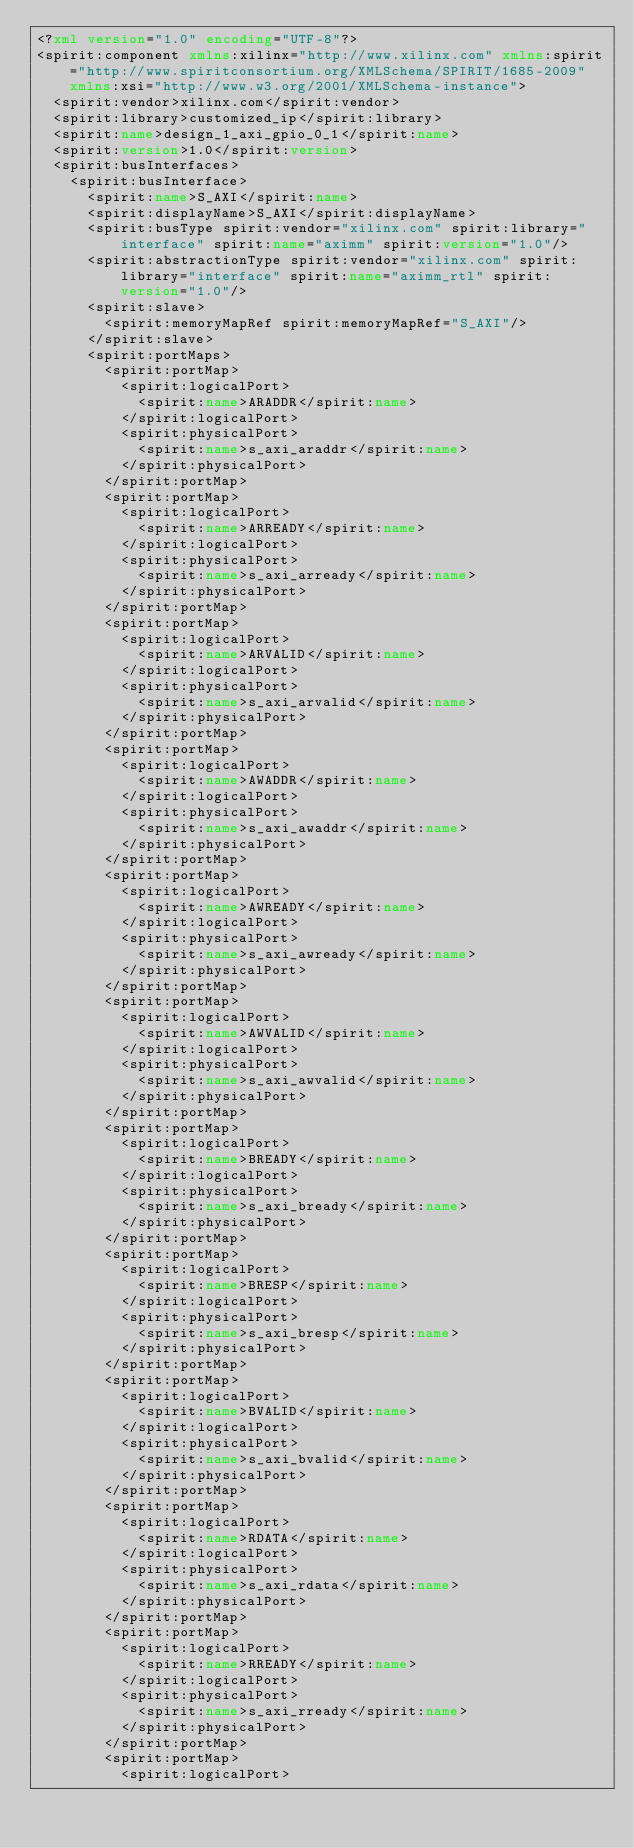<code> <loc_0><loc_0><loc_500><loc_500><_XML_><?xml version="1.0" encoding="UTF-8"?>
<spirit:component xmlns:xilinx="http://www.xilinx.com" xmlns:spirit="http://www.spiritconsortium.org/XMLSchema/SPIRIT/1685-2009" xmlns:xsi="http://www.w3.org/2001/XMLSchema-instance">
  <spirit:vendor>xilinx.com</spirit:vendor>
  <spirit:library>customized_ip</spirit:library>
  <spirit:name>design_1_axi_gpio_0_1</spirit:name>
  <spirit:version>1.0</spirit:version>
  <spirit:busInterfaces>
    <spirit:busInterface>
      <spirit:name>S_AXI</spirit:name>
      <spirit:displayName>S_AXI</spirit:displayName>
      <spirit:busType spirit:vendor="xilinx.com" spirit:library="interface" spirit:name="aximm" spirit:version="1.0"/>
      <spirit:abstractionType spirit:vendor="xilinx.com" spirit:library="interface" spirit:name="aximm_rtl" spirit:version="1.0"/>
      <spirit:slave>
        <spirit:memoryMapRef spirit:memoryMapRef="S_AXI"/>
      </spirit:slave>
      <spirit:portMaps>
        <spirit:portMap>
          <spirit:logicalPort>
            <spirit:name>ARADDR</spirit:name>
          </spirit:logicalPort>
          <spirit:physicalPort>
            <spirit:name>s_axi_araddr</spirit:name>
          </spirit:physicalPort>
        </spirit:portMap>
        <spirit:portMap>
          <spirit:logicalPort>
            <spirit:name>ARREADY</spirit:name>
          </spirit:logicalPort>
          <spirit:physicalPort>
            <spirit:name>s_axi_arready</spirit:name>
          </spirit:physicalPort>
        </spirit:portMap>
        <spirit:portMap>
          <spirit:logicalPort>
            <spirit:name>ARVALID</spirit:name>
          </spirit:logicalPort>
          <spirit:physicalPort>
            <spirit:name>s_axi_arvalid</spirit:name>
          </spirit:physicalPort>
        </spirit:portMap>
        <spirit:portMap>
          <spirit:logicalPort>
            <spirit:name>AWADDR</spirit:name>
          </spirit:logicalPort>
          <spirit:physicalPort>
            <spirit:name>s_axi_awaddr</spirit:name>
          </spirit:physicalPort>
        </spirit:portMap>
        <spirit:portMap>
          <spirit:logicalPort>
            <spirit:name>AWREADY</spirit:name>
          </spirit:logicalPort>
          <spirit:physicalPort>
            <spirit:name>s_axi_awready</spirit:name>
          </spirit:physicalPort>
        </spirit:portMap>
        <spirit:portMap>
          <spirit:logicalPort>
            <spirit:name>AWVALID</spirit:name>
          </spirit:logicalPort>
          <spirit:physicalPort>
            <spirit:name>s_axi_awvalid</spirit:name>
          </spirit:physicalPort>
        </spirit:portMap>
        <spirit:portMap>
          <spirit:logicalPort>
            <spirit:name>BREADY</spirit:name>
          </spirit:logicalPort>
          <spirit:physicalPort>
            <spirit:name>s_axi_bready</spirit:name>
          </spirit:physicalPort>
        </spirit:portMap>
        <spirit:portMap>
          <spirit:logicalPort>
            <spirit:name>BRESP</spirit:name>
          </spirit:logicalPort>
          <spirit:physicalPort>
            <spirit:name>s_axi_bresp</spirit:name>
          </spirit:physicalPort>
        </spirit:portMap>
        <spirit:portMap>
          <spirit:logicalPort>
            <spirit:name>BVALID</spirit:name>
          </spirit:logicalPort>
          <spirit:physicalPort>
            <spirit:name>s_axi_bvalid</spirit:name>
          </spirit:physicalPort>
        </spirit:portMap>
        <spirit:portMap>
          <spirit:logicalPort>
            <spirit:name>RDATA</spirit:name>
          </spirit:logicalPort>
          <spirit:physicalPort>
            <spirit:name>s_axi_rdata</spirit:name>
          </spirit:physicalPort>
        </spirit:portMap>
        <spirit:portMap>
          <spirit:logicalPort>
            <spirit:name>RREADY</spirit:name>
          </spirit:logicalPort>
          <spirit:physicalPort>
            <spirit:name>s_axi_rready</spirit:name>
          </spirit:physicalPort>
        </spirit:portMap>
        <spirit:portMap>
          <spirit:logicalPort></code> 